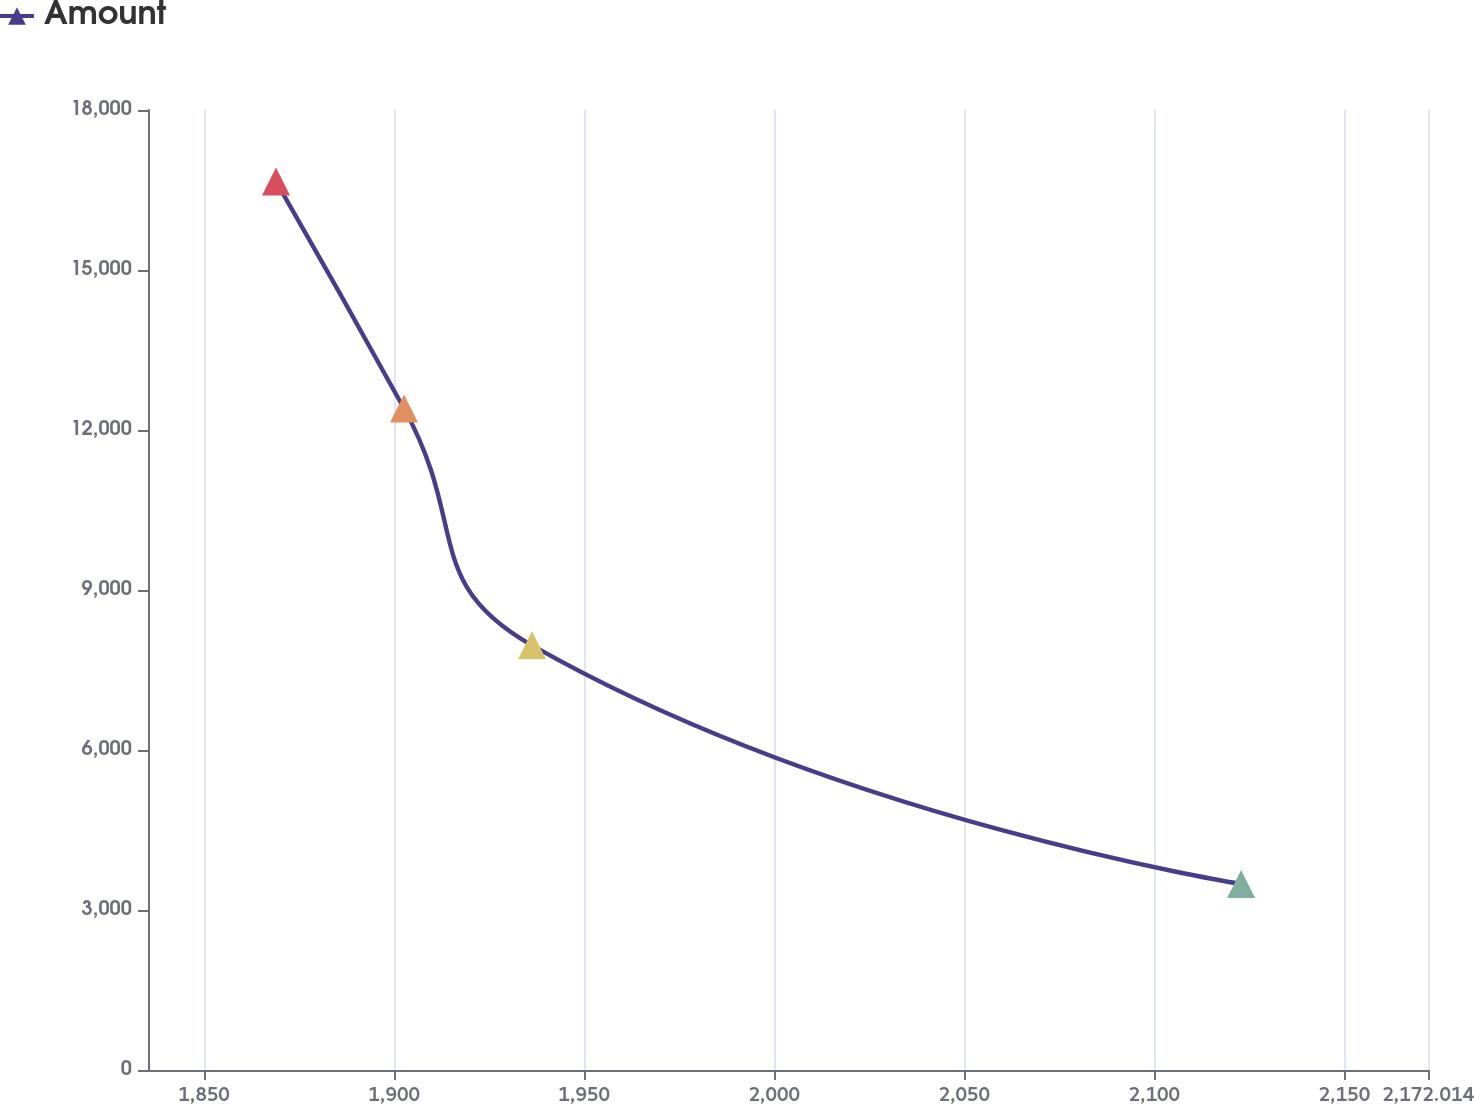<chart> <loc_0><loc_0><loc_500><loc_500><line_chart><ecel><fcel>Amount<nl><fcel>1868.93<fcel>16659.9<nl><fcel>1902.61<fcel>12404<nl><fcel>1936.29<fcel>7962.36<nl><fcel>2122.85<fcel>3488.28<nl><fcel>2205.69<fcel>1083.24<nl></chart> 